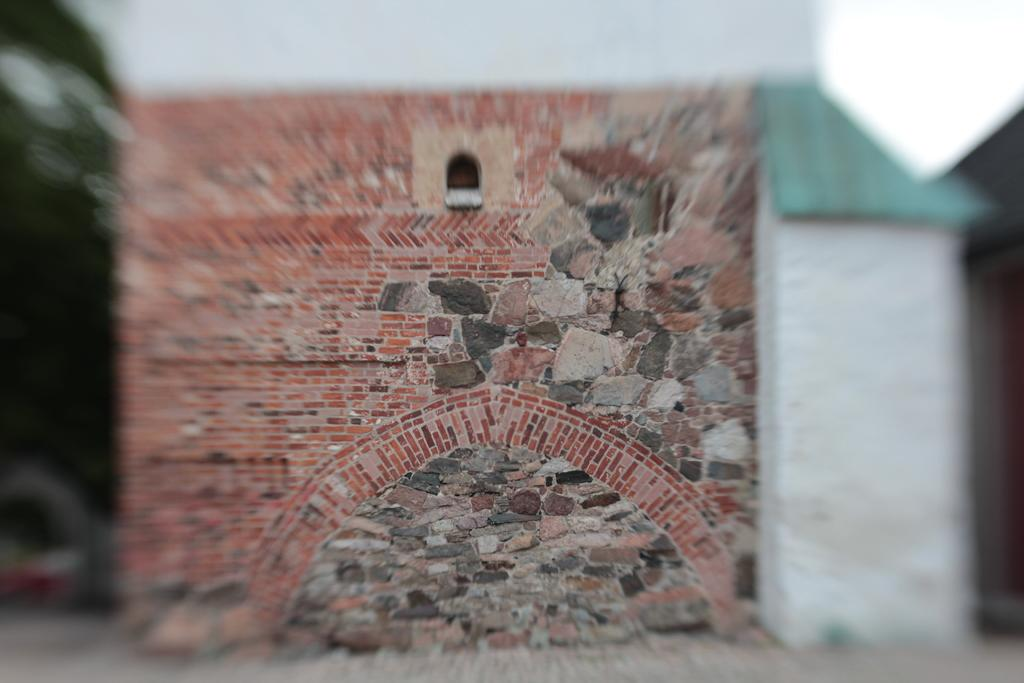What type of structure is present in the image? There is a building in the image. What part of the natural environment is visible in the image? The sky is visible in the image. What type of seed can be seen growing on the building in the image? There is no seed growing on the building in the image. What type of arch is present in the image? There is no arch present in the image. 